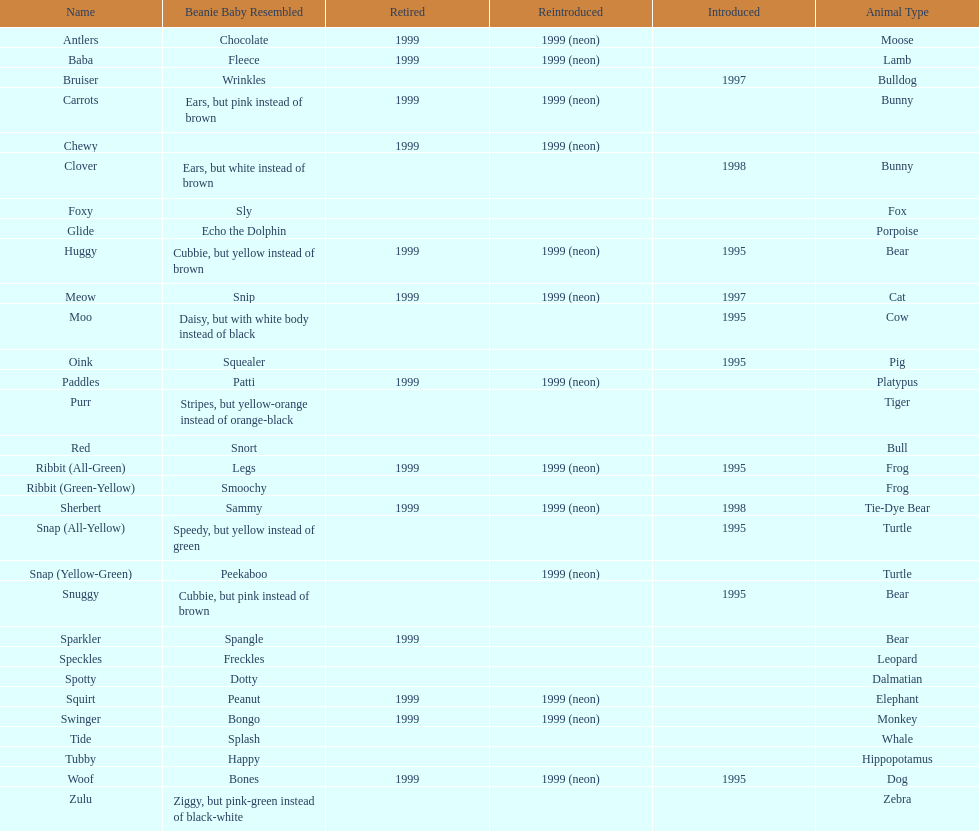Name the only pillow pal that is a dalmatian. Spotty. 